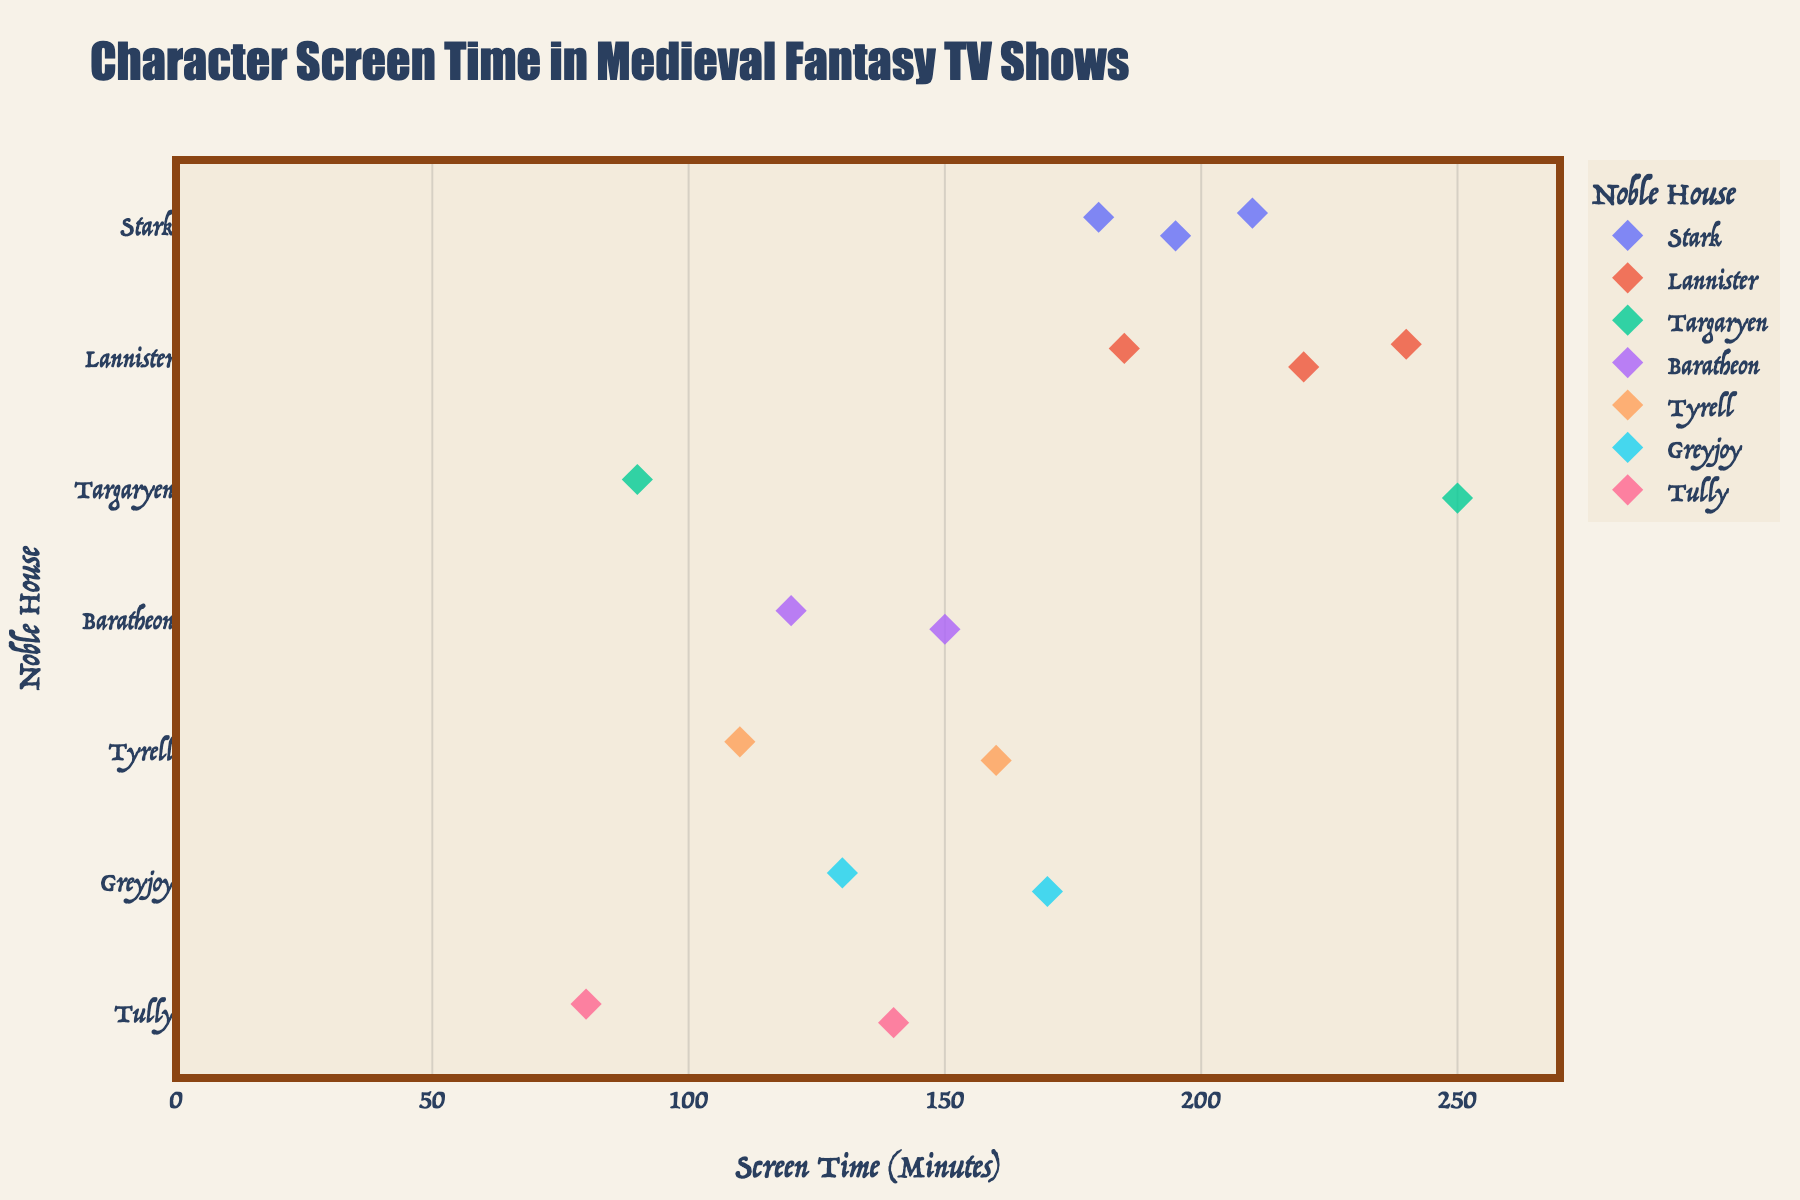Which character has the highest screen time? First, look for the highest data point on the x-axis. Identify the associated character from the hover data.
Answer: Daenerys Targaryen What is the average screen time of the Stark characters? Sum the screen times of all Stark characters (Eddard: 180, Arya: 210, Sansa: 195) and divide by 3. (180 + 210 + 195) / 3 = 585 / 3
Answer: 195 Which noble house has the character with the least screen time? Look for the smallest data point on the x-axis. Identify the corresponding noble house from the y-axis.
Answer: Tully How many characters have a screen time greater than 200 minutes? Count the data points that are positioned beyond the 200-minute mark on the x-axis.
Answer: 4 What is the total screen time of all Lannister characters? Sum the screen times of all Lannister characters (Tyrion: 240, Cersei: 220, Jaime: 185). 240 + 220 + 185 = 645
Answer: 645 Which house has the most variation in screen time among its characters? Compare the range (difference between maximum and minimum screen times) for each house. Stark: 210 - 180 = 30, Lannister: 240 - 185 = 55, Targaryen: 250 - 90 = 160, etc. Identify the house with the largest range.
Answer: Targaryen Are there more male or female characters in this dataset, based on screen time data? Count the male and female characters from each house, as inferred from the names and known characters. Identify the group with the higher count.
Answer: Female Which character from House Baratheon has less screen time? Compare the screen times of Robert (120) and Stannis (150).
Answer: Robert Baratheon Is there any character from House Tyrell with over 150 minutes of screen time? Check if any of the data points for House Tyrell exceed the 150-minute mark. Note the screen time of Margaery (160) and Olenna (110).
Answer: Yes What is the difference in screen time between the characters with the maximum and minimum values? Subtract the smallest screen time value (Edmure Tully: 80) from the highest screen time value (Daenerys Targaryen: 250). 250 - 80 = 170
Answer: 170 